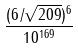Convert formula to latex. <formula><loc_0><loc_0><loc_500><loc_500>\frac { ( 6 / \sqrt { 2 0 9 } ) ^ { 6 } } { 1 0 ^ { 1 6 9 } }</formula> 